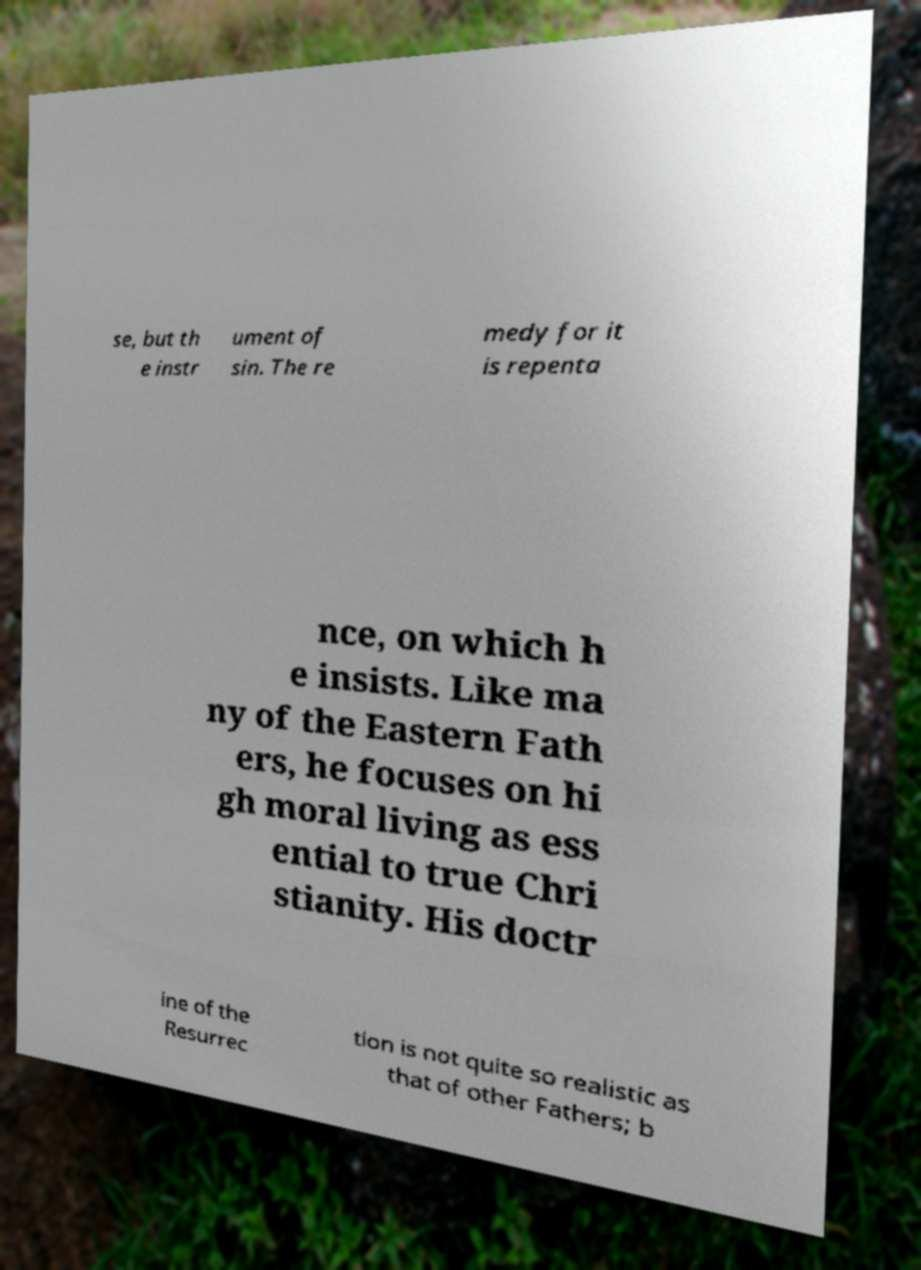For documentation purposes, I need the text within this image transcribed. Could you provide that? se, but th e instr ument of sin. The re medy for it is repenta nce, on which h e insists. Like ma ny of the Eastern Fath ers, he focuses on hi gh moral living as ess ential to true Chri stianity. His doctr ine of the Resurrec tion is not quite so realistic as that of other Fathers; b 